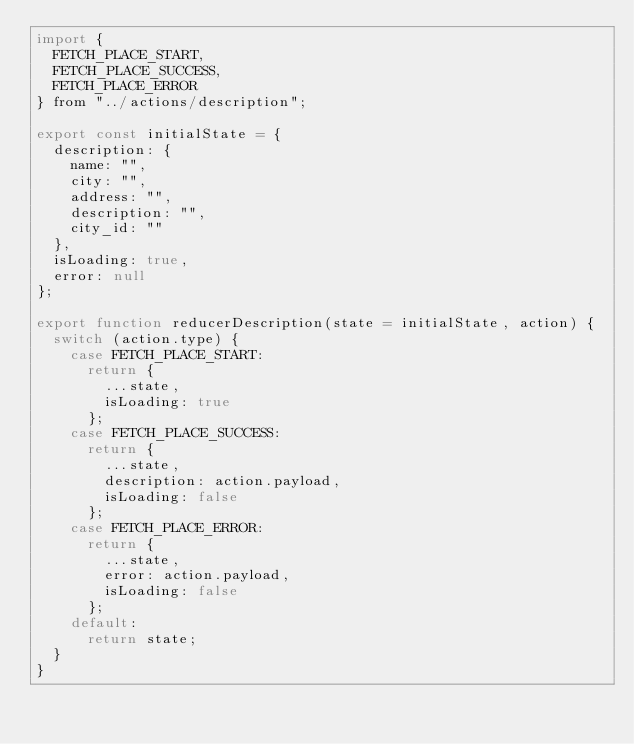<code> <loc_0><loc_0><loc_500><loc_500><_JavaScript_>import {
  FETCH_PLACE_START,
  FETCH_PLACE_SUCCESS,
  FETCH_PLACE_ERROR
} from "../actions/description";

export const initialState = {
  description: {
    name: "",
    city: "",
    address: "",
    description: "",
    city_id: ""
  },
  isLoading: true,
  error: null
};

export function reducerDescription(state = initialState, action) {
  switch (action.type) {
    case FETCH_PLACE_START:
      return {
        ...state,
        isLoading: true
      };
    case FETCH_PLACE_SUCCESS:
      return {
        ...state,
        description: action.payload,
        isLoading: false
      };
    case FETCH_PLACE_ERROR:
      return {
        ...state,
        error: action.payload,
        isLoading: false
      };
    default:
      return state;
  }
}
</code> 